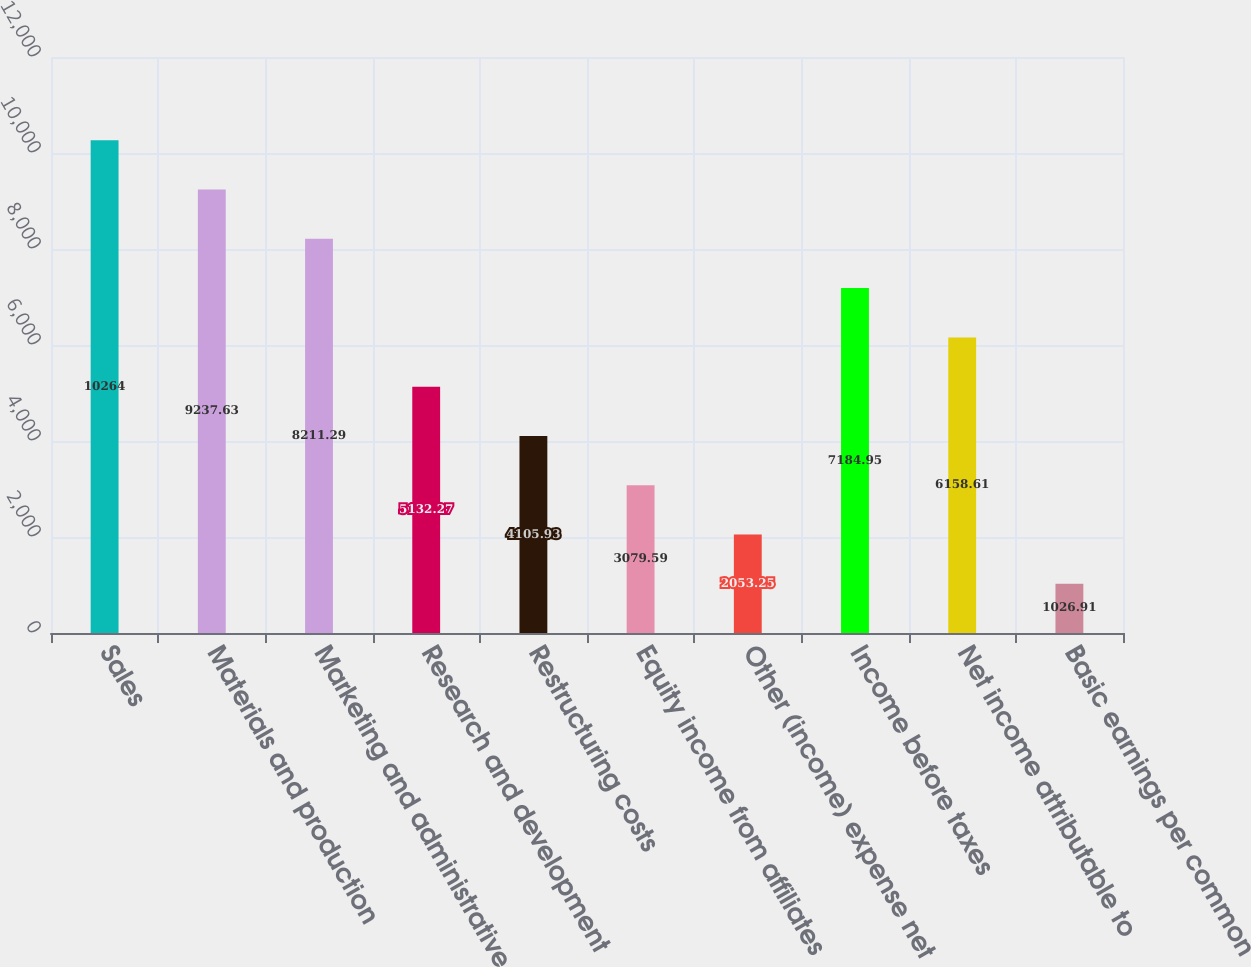<chart> <loc_0><loc_0><loc_500><loc_500><bar_chart><fcel>Sales<fcel>Materials and production<fcel>Marketing and administrative<fcel>Research and development<fcel>Restructuring costs<fcel>Equity income from affiliates<fcel>Other (income) expense net<fcel>Income before taxes<fcel>Net income attributable to<fcel>Basic earnings per common<nl><fcel>10264<fcel>9237.63<fcel>8211.29<fcel>5132.27<fcel>4105.93<fcel>3079.59<fcel>2053.25<fcel>7184.95<fcel>6158.61<fcel>1026.91<nl></chart> 